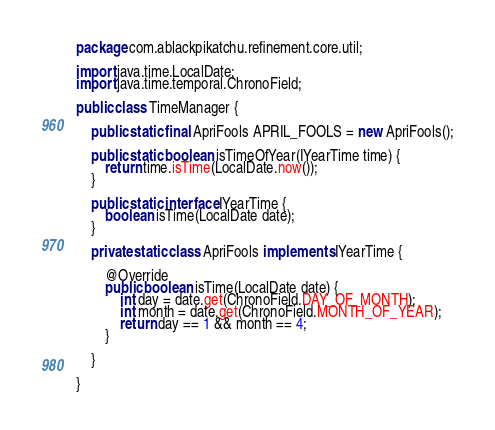<code> <loc_0><loc_0><loc_500><loc_500><_Java_>package com.ablackpikatchu.refinement.core.util;

import java.time.LocalDate;
import java.time.temporal.ChronoField;

public class TimeManager {
	
	public static final ApriFools APRIL_FOOLS = new ApriFools();
	
	public static boolean isTimeOfYear(IYearTime time) {
		return time.isTime(LocalDate.now());
	}
	
	public static interface IYearTime {
		boolean isTime(LocalDate date);
	}
	
	private static class ApriFools implements IYearTime {

		@Override
		public boolean isTime(LocalDate date) {
			int day = date.get(ChronoField.DAY_OF_MONTH);
	        int month = date.get(ChronoField.MONTH_OF_YEAR);
	        return day == 1 && month == 4;
		}
		
	}

}
</code> 